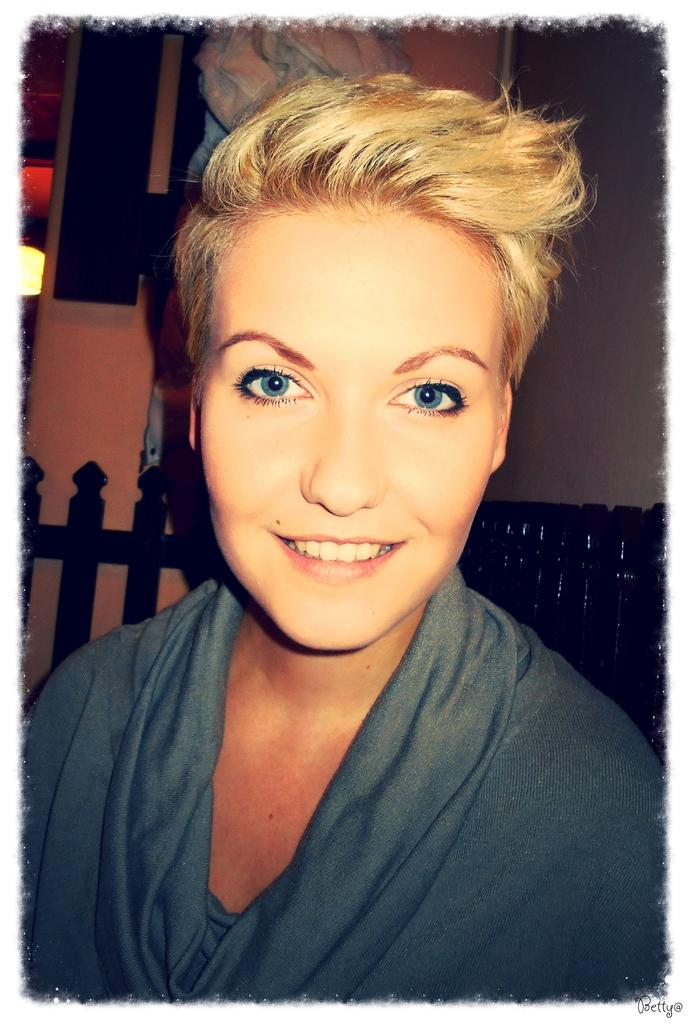Who or what is the main subject in the image? There is a person in the center of the image. What is the person doing or expressing in the image? The person is smiling. What can be seen behind the person in the image? There is a wall in the background of the image, along with a few other objects. What type of rock is the person using to stop the car in the image? There is no car or rock present in the image; it features a person smiling in front of a wall and other objects. 